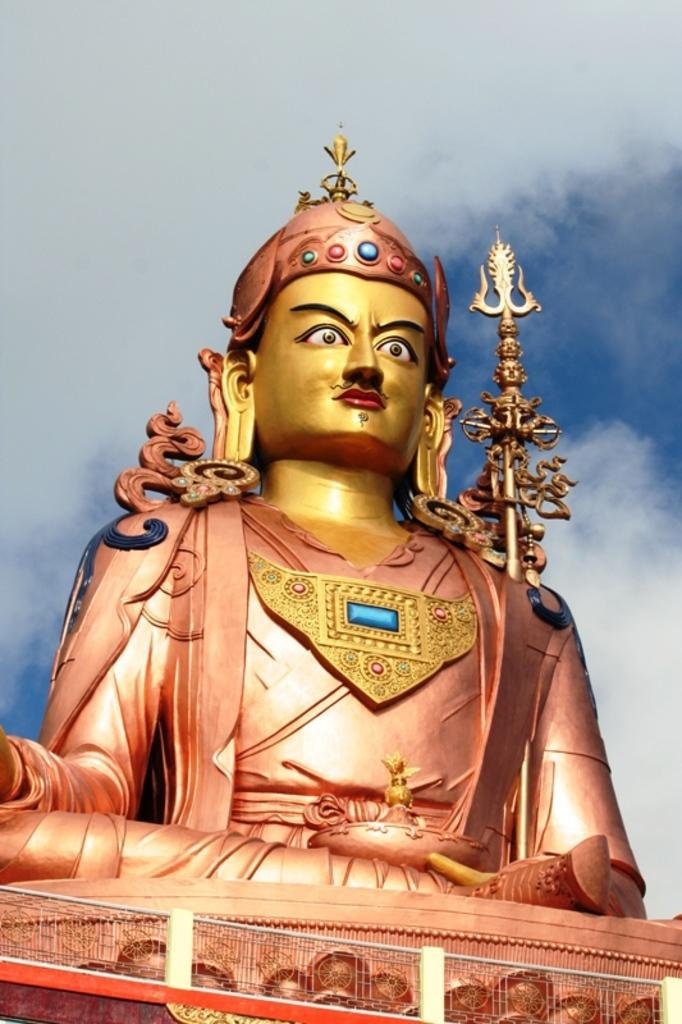Could you give a brief overview of what you see in this image? The picture consists of a sculpture. At the bottom there is railing. Sky is cloudy. 